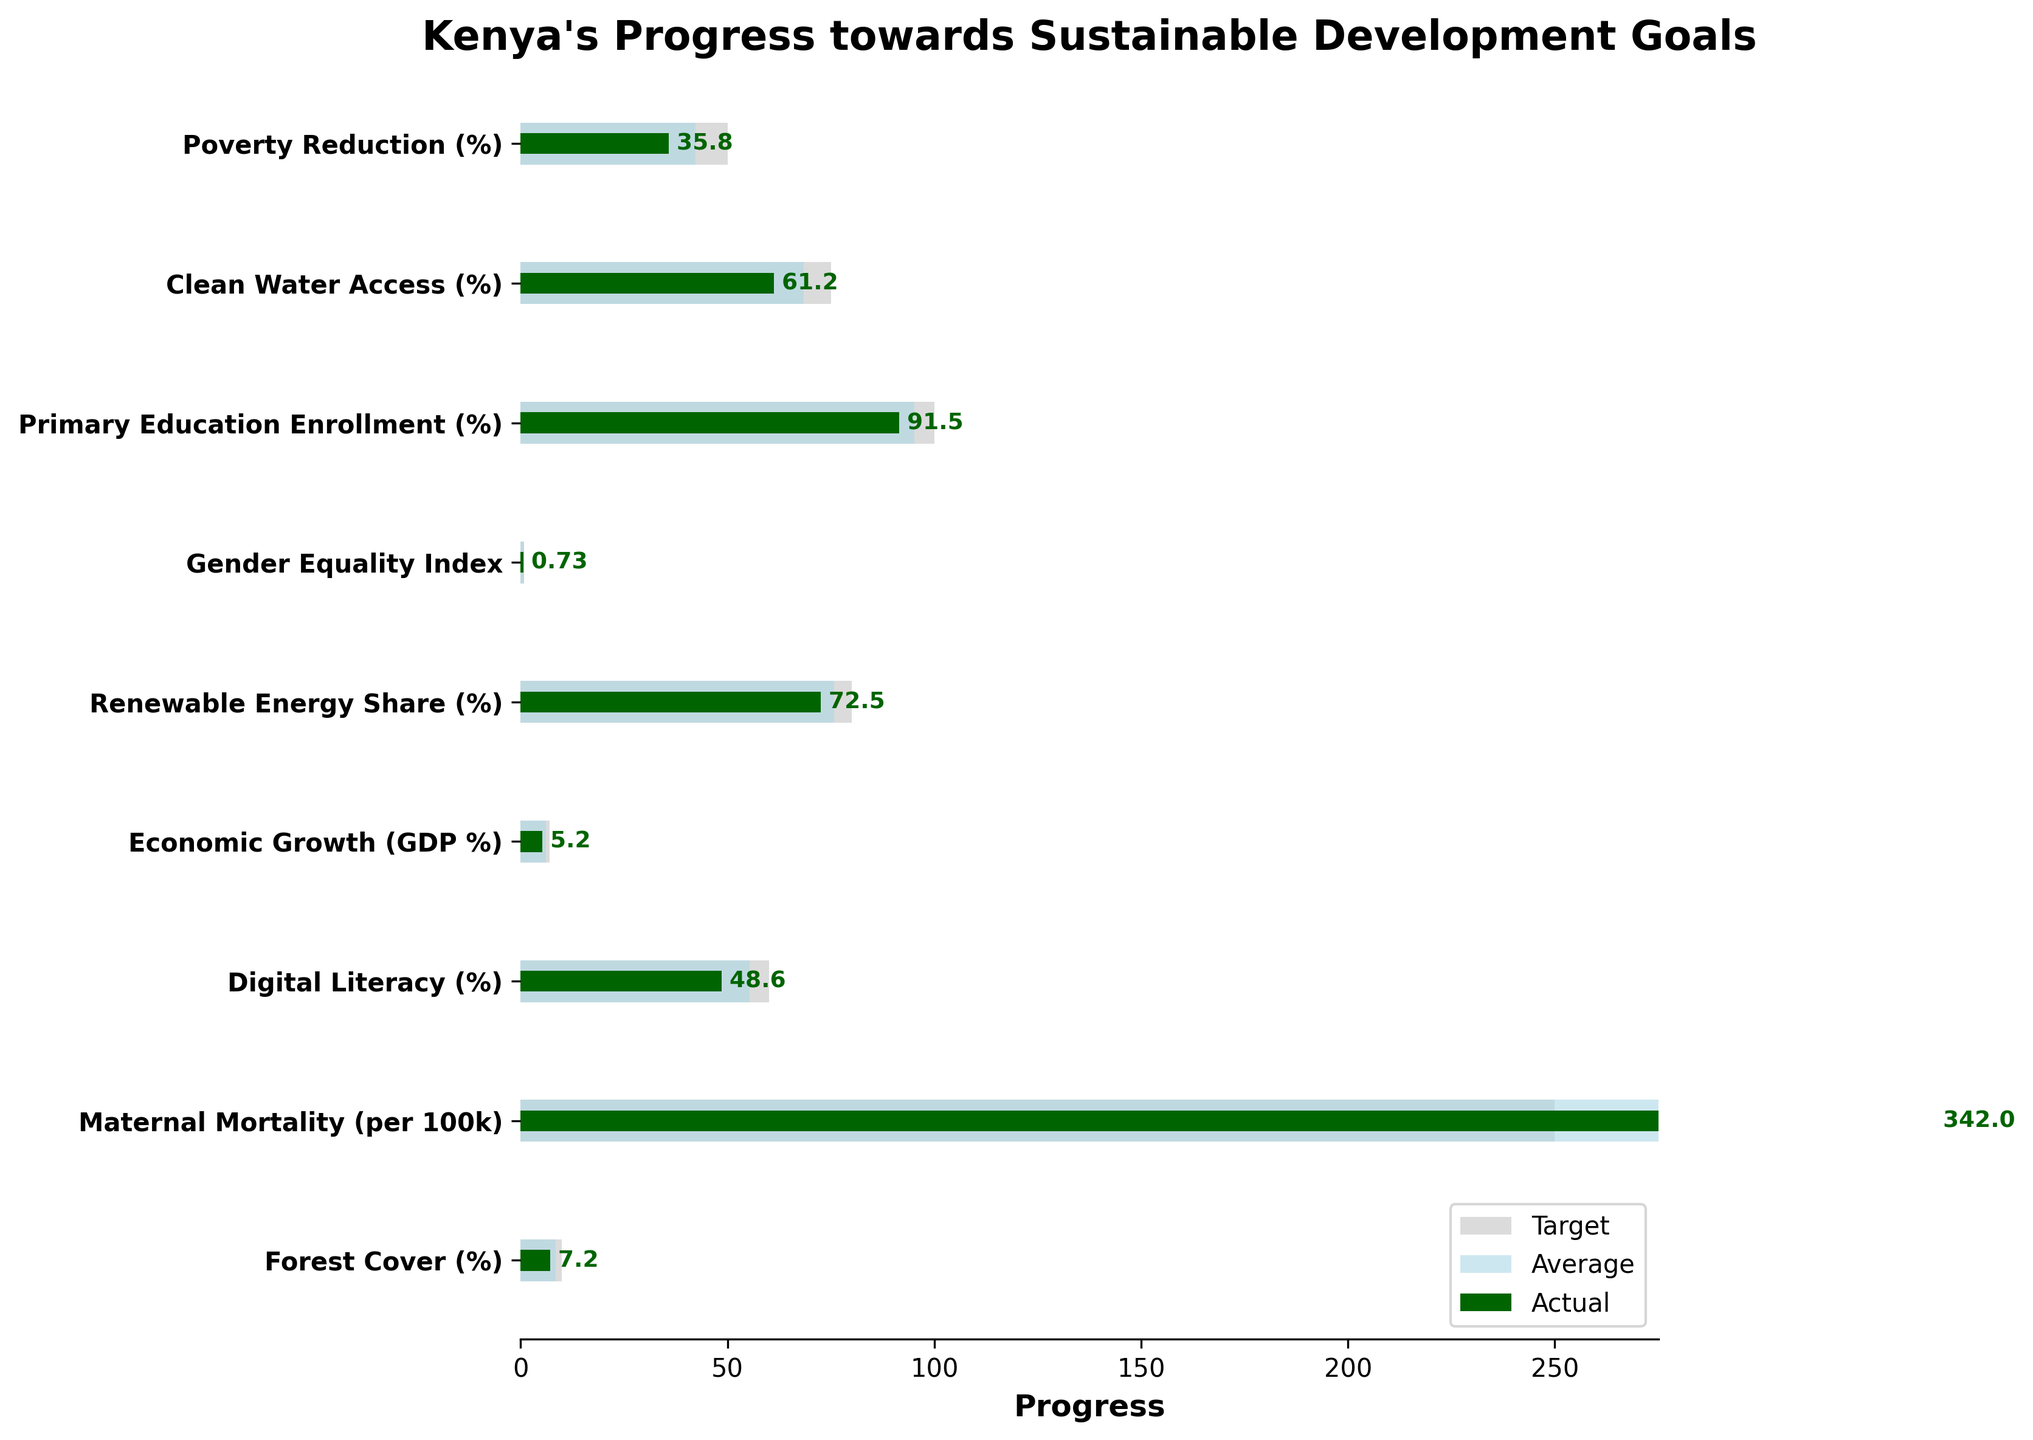What is the title of the figure? The title is located at the top of the figure, clearly stating the purpose of the chart.
Answer: Kenya's Progress towards Sustainable Development Goals How many categories are included in the figure? Count the number of y-axis labels in the figure, which represents different categories.
Answer: 9 Which category has the highest actual value? Compare all the actual values represented by the darkest bars and identify the highest one.
Answer: Primary Education Enrollment (%) What is the target value for Maternal Mortality (per 100k)? Look at the bar representing the target for Maternal Mortality, indicated by the light gray color.
Answer: 250 How much is the difference between the actual and target values for Forest Cover (%)? Subtract the actual value from the target value. Target (10) - Actual (7.2)
Answer: 2.8 What is the value of the Gender Equality Index compared to the target? Identify both the actual and target values for Gender Equality Index and compare them.
Answer: Actual: 0.73, Target: 0.85 Which category shows the closest actual value to its comparison value? Compare all categories by looking at their actual and comparison bars, and find the smallest difference.
Answer: Primary Education Enrollment (%) For which category is the actual value significantly lower than both the target and comparison values? Identify the category where the dark green bar is significantly shorter than both the light gray and light blue bars.
Answer: Maternal Mortality (per 100k) What is the highest target value in all categories, and which category does it belong to? Observe all target values and identify the highest one.
Answer: 100, Primary Education Enrollment (%) Which categories have actual values above 70%? List the categories where the dark green bar represents values above 70%.
Answer: Clean Water Access (%), Primary Education Enrollment (%), Renewable Energy Share (%), Gender Equality Index 